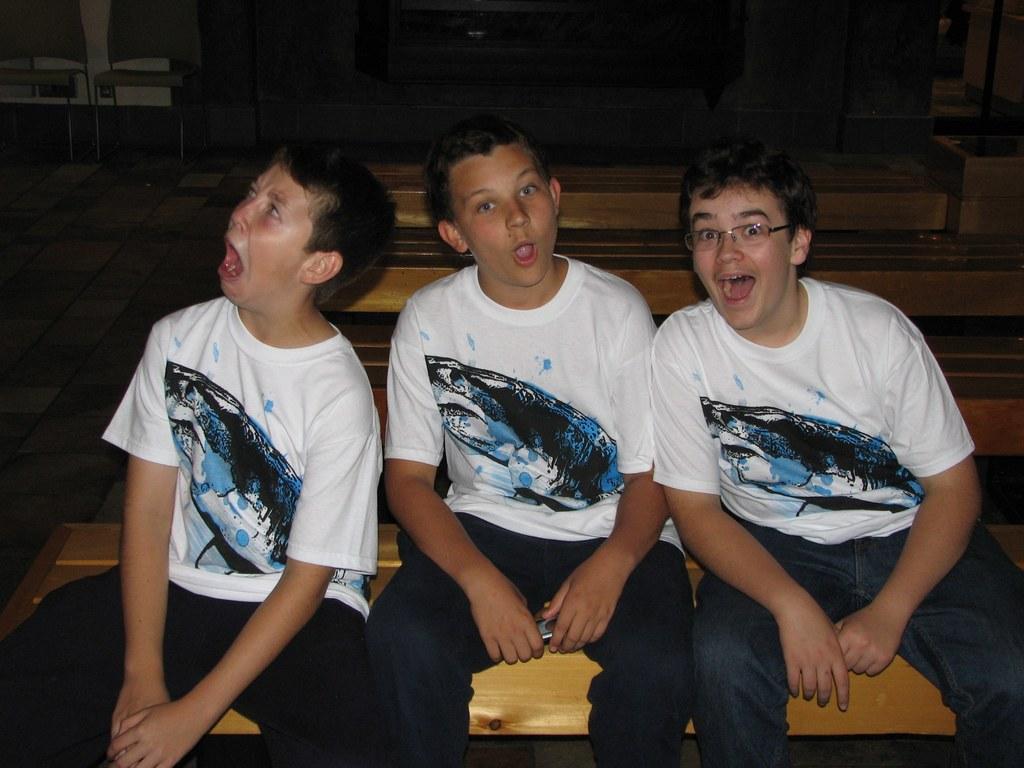Could you give a brief overview of what you see in this image? In this picture I can observe three boys sitting on the bench. All of them are wearing white color T shirts and one of them is wearing spectacles. The background is dark. 